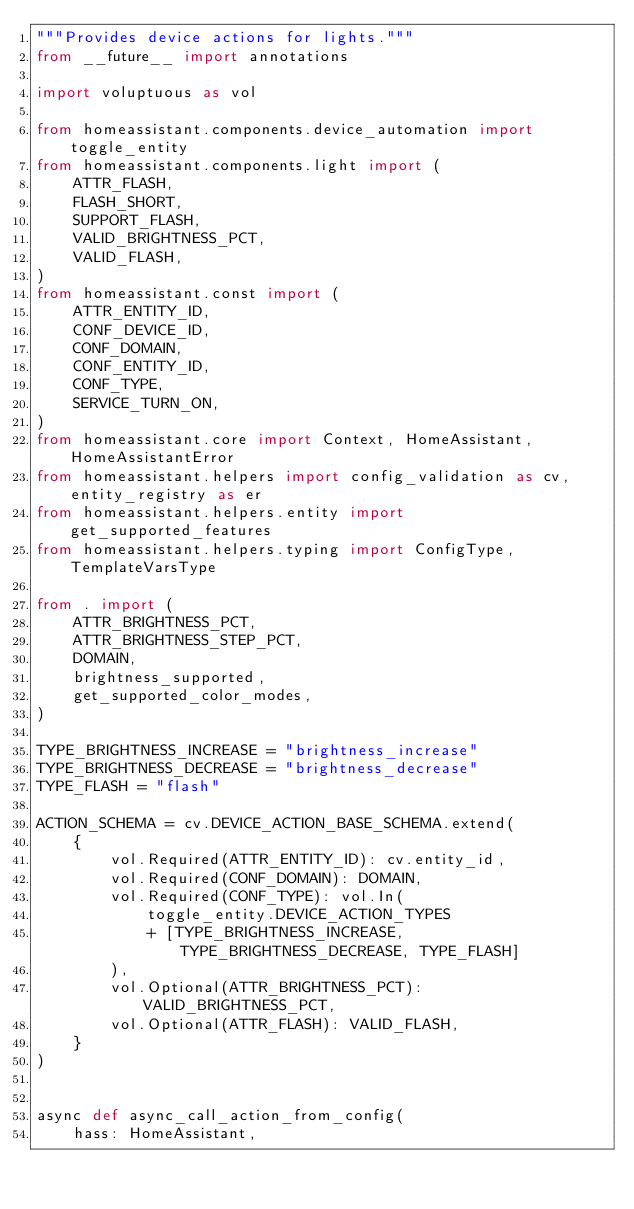Convert code to text. <code><loc_0><loc_0><loc_500><loc_500><_Python_>"""Provides device actions for lights."""
from __future__ import annotations

import voluptuous as vol

from homeassistant.components.device_automation import toggle_entity
from homeassistant.components.light import (
    ATTR_FLASH,
    FLASH_SHORT,
    SUPPORT_FLASH,
    VALID_BRIGHTNESS_PCT,
    VALID_FLASH,
)
from homeassistant.const import (
    ATTR_ENTITY_ID,
    CONF_DEVICE_ID,
    CONF_DOMAIN,
    CONF_ENTITY_ID,
    CONF_TYPE,
    SERVICE_TURN_ON,
)
from homeassistant.core import Context, HomeAssistant, HomeAssistantError
from homeassistant.helpers import config_validation as cv, entity_registry as er
from homeassistant.helpers.entity import get_supported_features
from homeassistant.helpers.typing import ConfigType, TemplateVarsType

from . import (
    ATTR_BRIGHTNESS_PCT,
    ATTR_BRIGHTNESS_STEP_PCT,
    DOMAIN,
    brightness_supported,
    get_supported_color_modes,
)

TYPE_BRIGHTNESS_INCREASE = "brightness_increase"
TYPE_BRIGHTNESS_DECREASE = "brightness_decrease"
TYPE_FLASH = "flash"

ACTION_SCHEMA = cv.DEVICE_ACTION_BASE_SCHEMA.extend(
    {
        vol.Required(ATTR_ENTITY_ID): cv.entity_id,
        vol.Required(CONF_DOMAIN): DOMAIN,
        vol.Required(CONF_TYPE): vol.In(
            toggle_entity.DEVICE_ACTION_TYPES
            + [TYPE_BRIGHTNESS_INCREASE, TYPE_BRIGHTNESS_DECREASE, TYPE_FLASH]
        ),
        vol.Optional(ATTR_BRIGHTNESS_PCT): VALID_BRIGHTNESS_PCT,
        vol.Optional(ATTR_FLASH): VALID_FLASH,
    }
)


async def async_call_action_from_config(
    hass: HomeAssistant,</code> 